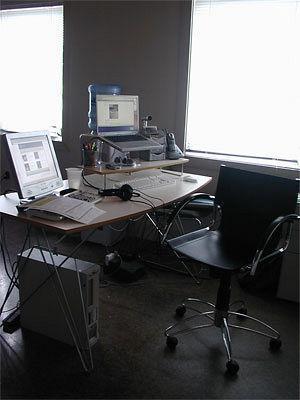This computer desk is in what type of building?
Make your selection and explain in format: 'Answer: answer
Rationale: rationale.'
Options: Dormitory, home, commercial office, apartment. Answer: commercial office.
Rationale: The desk is commercial. 